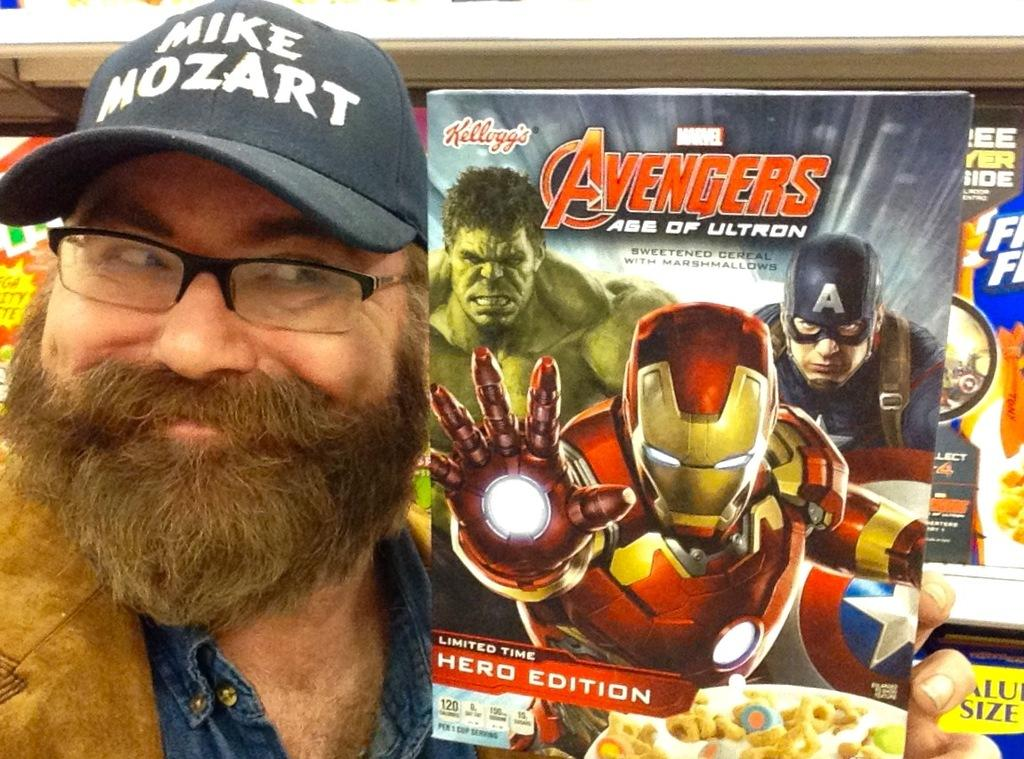What is present in the image? There is a person in the image. Can you describe the person's attire? The person is wearing a cap. What is the person holding in the image? The person is holding a book. What type of cake is being served at the peace rally in the image? There is no peace rally or cake present in the image; it features a person wearing a cap and holding a book. 